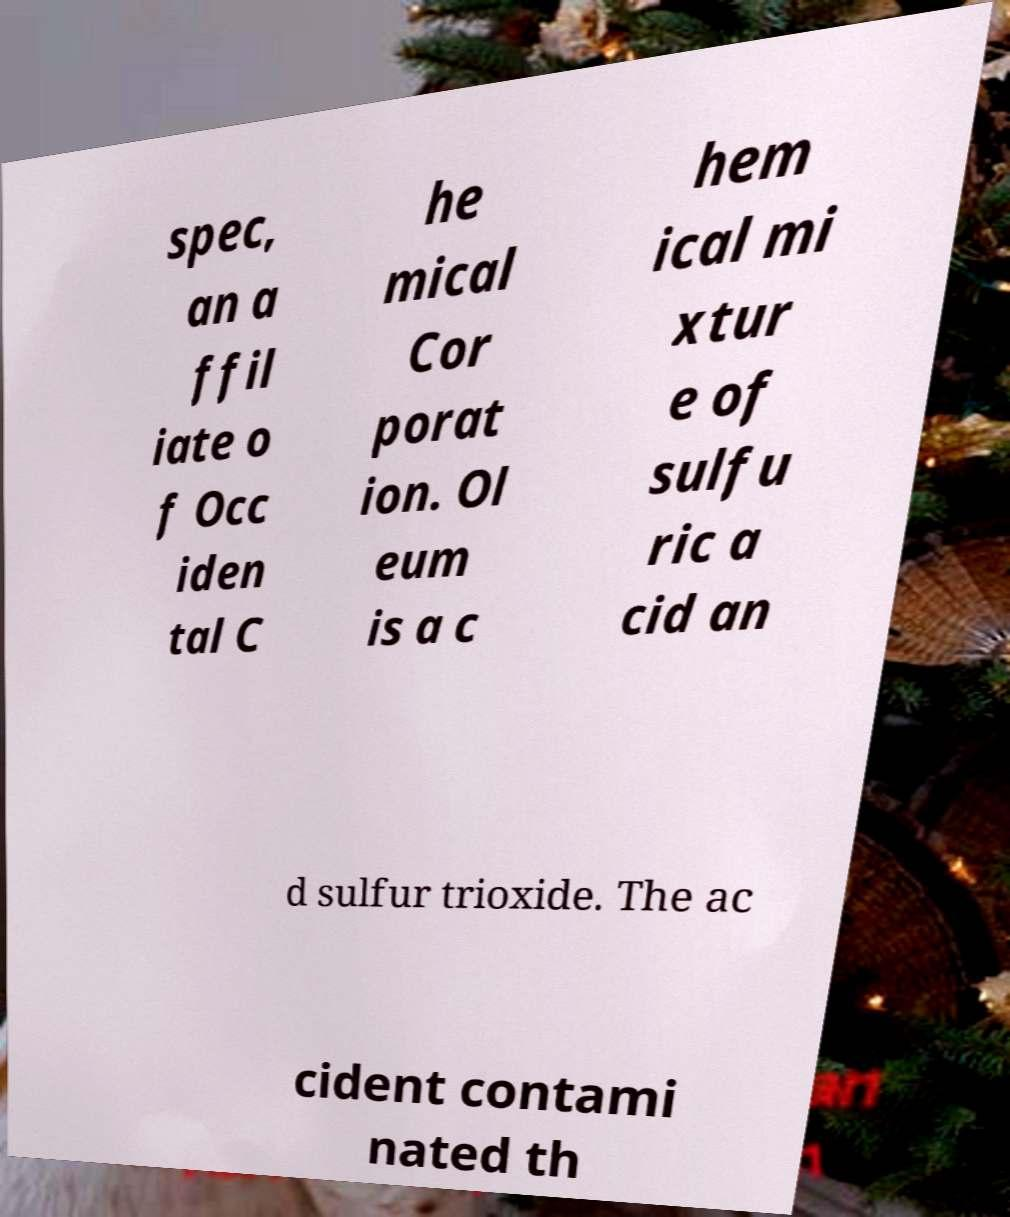Can you read and provide the text displayed in the image?This photo seems to have some interesting text. Can you extract and type it out for me? spec, an a ffil iate o f Occ iden tal C he mical Cor porat ion. Ol eum is a c hem ical mi xtur e of sulfu ric a cid an d sulfur trioxide. The ac cident contami nated th 